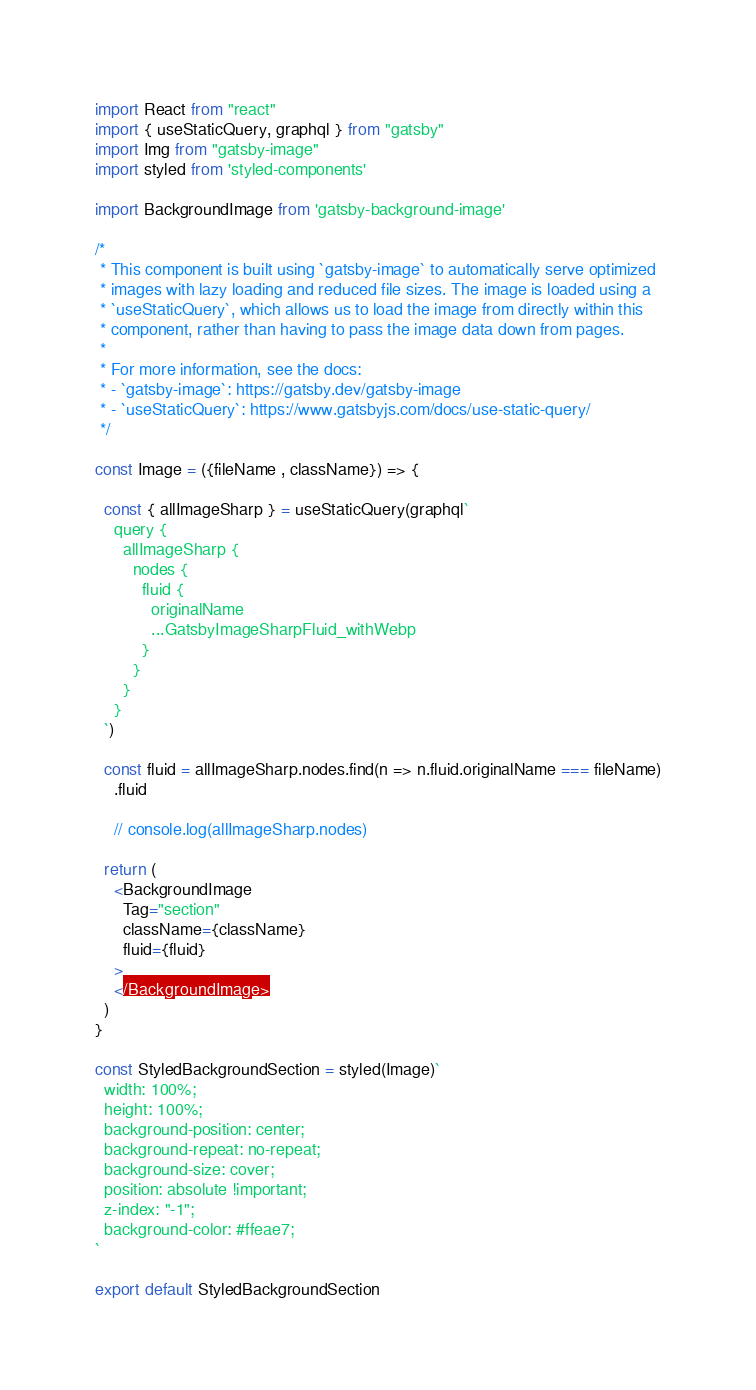<code> <loc_0><loc_0><loc_500><loc_500><_JavaScript_>import React from "react"
import { useStaticQuery, graphql } from "gatsby"
import Img from "gatsby-image"
import styled from 'styled-components'

import BackgroundImage from 'gatsby-background-image'

/*
 * This component is built using `gatsby-image` to automatically serve optimized
 * images with lazy loading and reduced file sizes. The image is loaded using a
 * `useStaticQuery`, which allows us to load the image from directly within this
 * component, rather than having to pass the image data down from pages.
 *
 * For more information, see the docs:
 * - `gatsby-image`: https://gatsby.dev/gatsby-image
 * - `useStaticQuery`: https://www.gatsbyjs.com/docs/use-static-query/
 */

const Image = ({fileName , className}) => {
  
  const { allImageSharp } = useStaticQuery(graphql`
    query {
      allImageSharp {
        nodes {
          fluid {
            originalName
            ...GatsbyImageSharpFluid_withWebp
          }
        }
      }
    }
  `)
  
  const fluid = allImageSharp.nodes.find(n => n.fluid.originalName === fileName)
    .fluid

    // console.log(allImageSharp.nodes)

  return (
    <BackgroundImage
      Tag="section"
      className={className}
      fluid={fluid}
    >
    </BackgroundImage>
  )
}

const StyledBackgroundSection = styled(Image)`
  width: 100%;
  height: 100%;
  background-position: center;
  background-repeat: no-repeat;
  background-size: cover;
  position: absolute !important;
  z-index: "-1";
  background-color: #ffeae7;
`

export default StyledBackgroundSection
</code> 